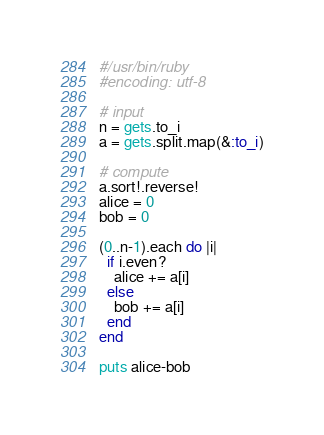Convert code to text. <code><loc_0><loc_0><loc_500><loc_500><_Ruby_>#/usr/bin/ruby
#encoding: utf-8

# input
n = gets.to_i
a = gets.split.map(&:to_i)

# compute
a.sort!.reverse!
alice = 0
bob = 0

(0..n-1).each do |i|
  if i.even?
    alice += a[i]
  else
    bob += a[i]
  end
end

puts alice-bob</code> 